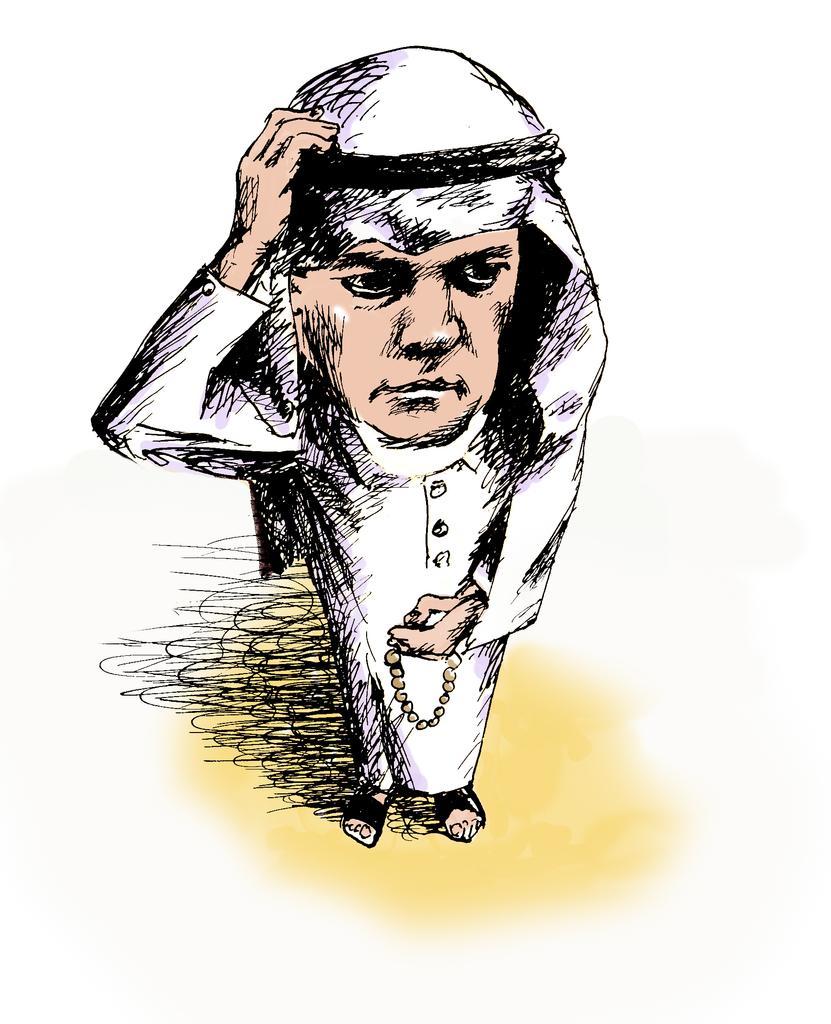Describe this image in one or two sentences. In this image I can see the sketch of the person and the person is wearing white color dress and I can see the white color background. 